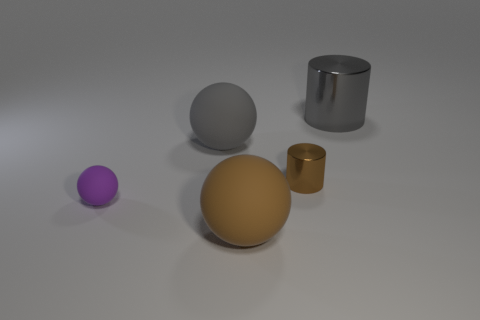There is a big gray thing on the right side of the brown cylinder; does it have the same shape as the tiny metallic object?
Make the answer very short. Yes. Are there more small things behind the tiny matte sphere than things behind the large shiny object?
Provide a succinct answer. Yes. There is a cylinder in front of the large shiny thing; how many brown things are in front of it?
Give a very brief answer. 1. How many other objects are the same color as the tiny ball?
Offer a terse response. 0. What is the color of the big ball that is in front of the rubber thing behind the purple ball?
Provide a succinct answer. Brown. Is there a large shiny cylinder of the same color as the small matte object?
Ensure brevity in your answer.  No. What number of shiny things are either large spheres or large gray cylinders?
Your answer should be very brief. 1. Is there a gray object made of the same material as the small purple ball?
Your answer should be compact. Yes. How many matte spheres are both in front of the small cylinder and right of the tiny rubber object?
Your response must be concise. 1. Is the number of large gray matte objects left of the small purple rubber sphere less than the number of matte balls behind the big brown sphere?
Give a very brief answer. Yes. 